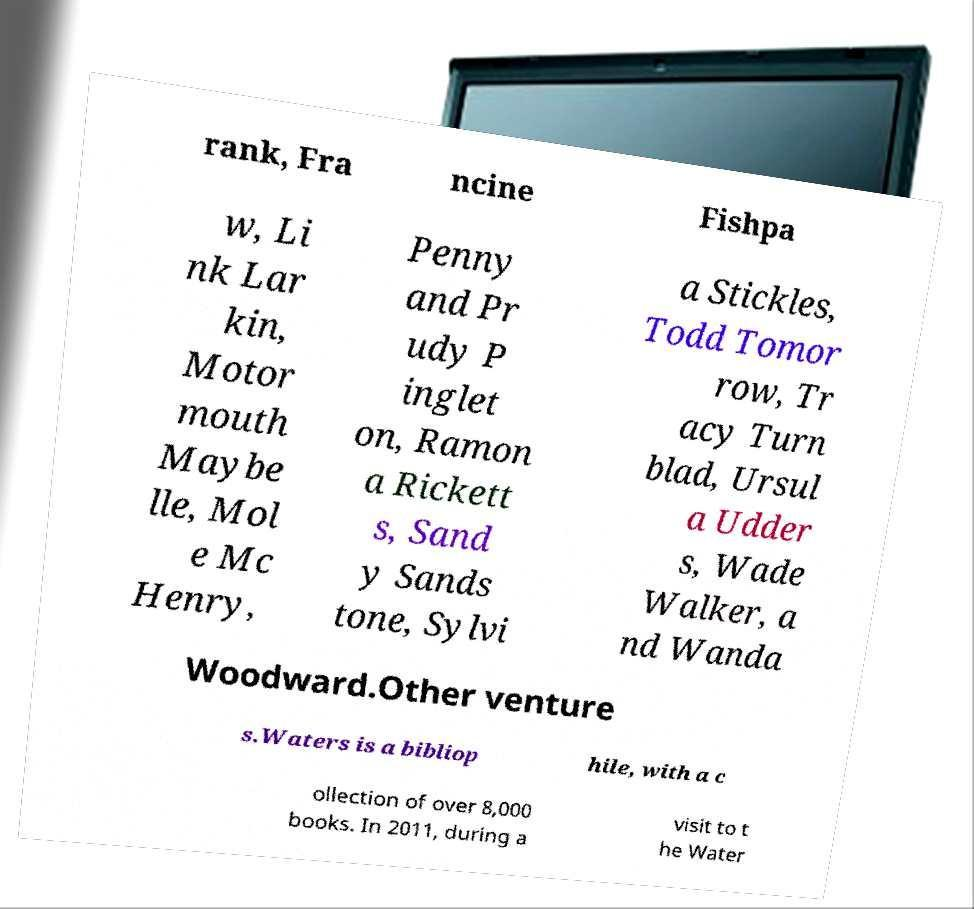Can you read and provide the text displayed in the image?This photo seems to have some interesting text. Can you extract and type it out for me? rank, Fra ncine Fishpa w, Li nk Lar kin, Motor mouth Maybe lle, Mol e Mc Henry, Penny and Pr udy P inglet on, Ramon a Rickett s, Sand y Sands tone, Sylvi a Stickles, Todd Tomor row, Tr acy Turn blad, Ursul a Udder s, Wade Walker, a nd Wanda Woodward.Other venture s.Waters is a bibliop hile, with a c ollection of over 8,000 books. In 2011, during a visit to t he Water 